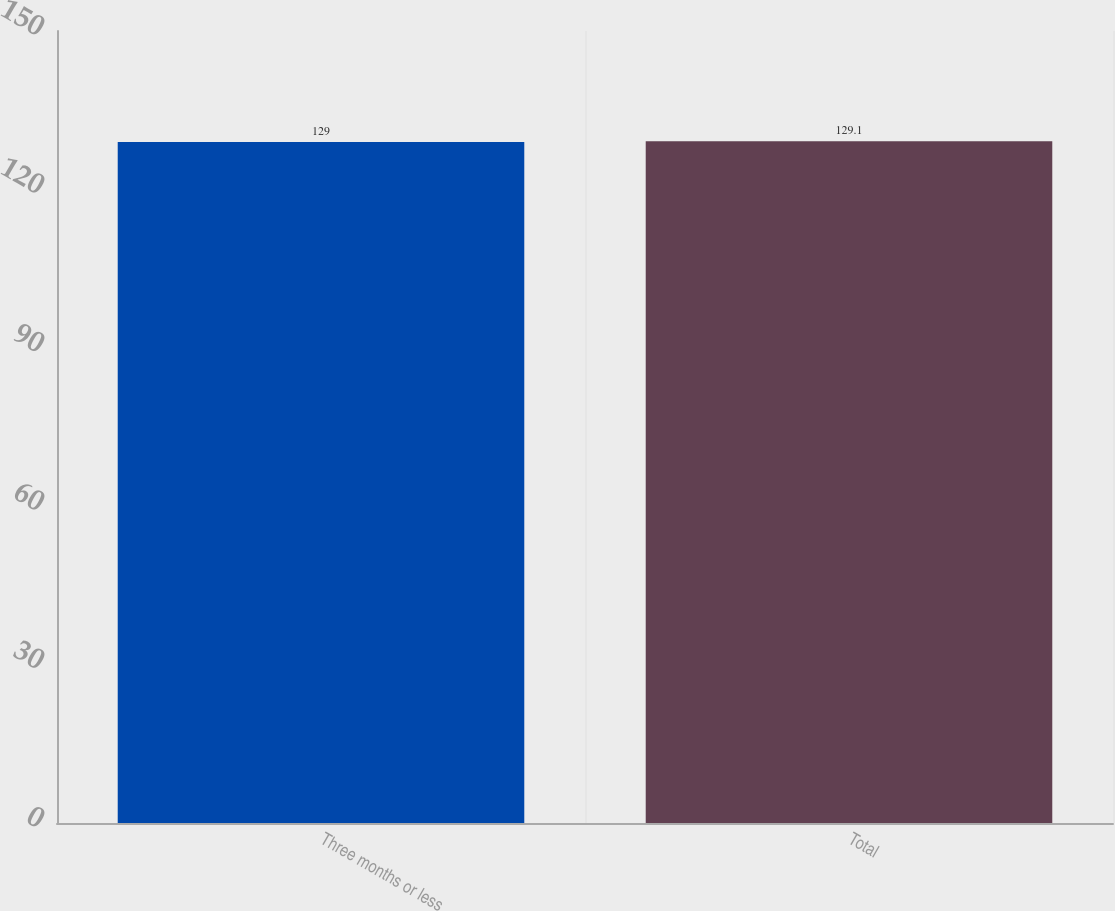<chart> <loc_0><loc_0><loc_500><loc_500><bar_chart><fcel>Three months or less<fcel>Total<nl><fcel>129<fcel>129.1<nl></chart> 